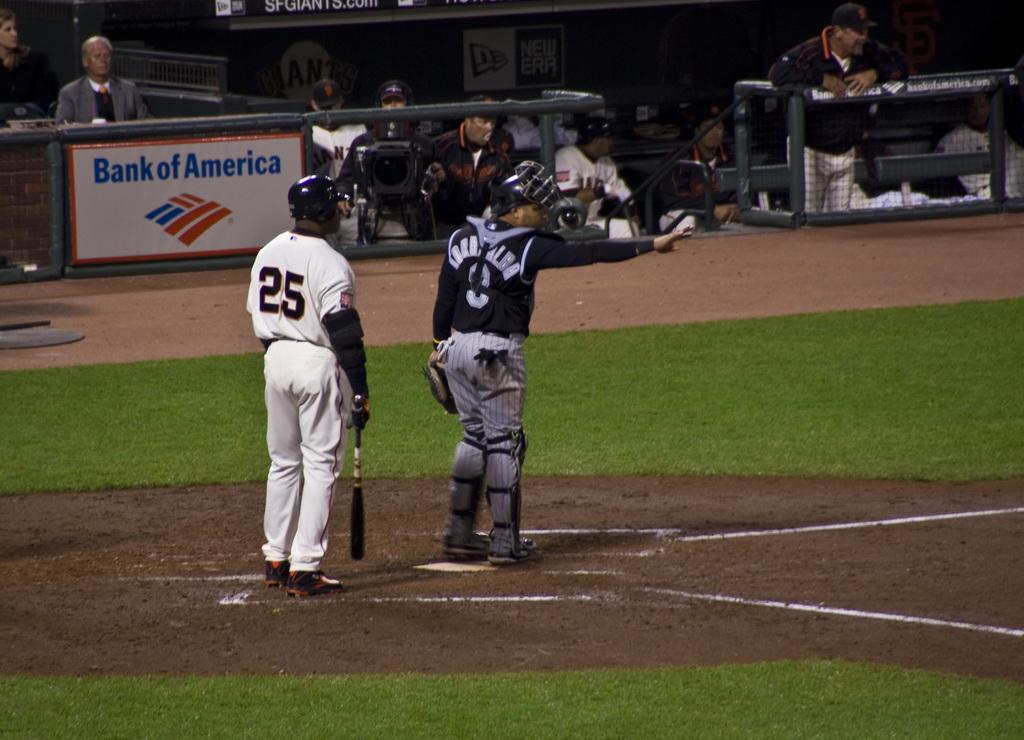Does bank of america sponsor this game?
Your answer should be compact. Yes. 